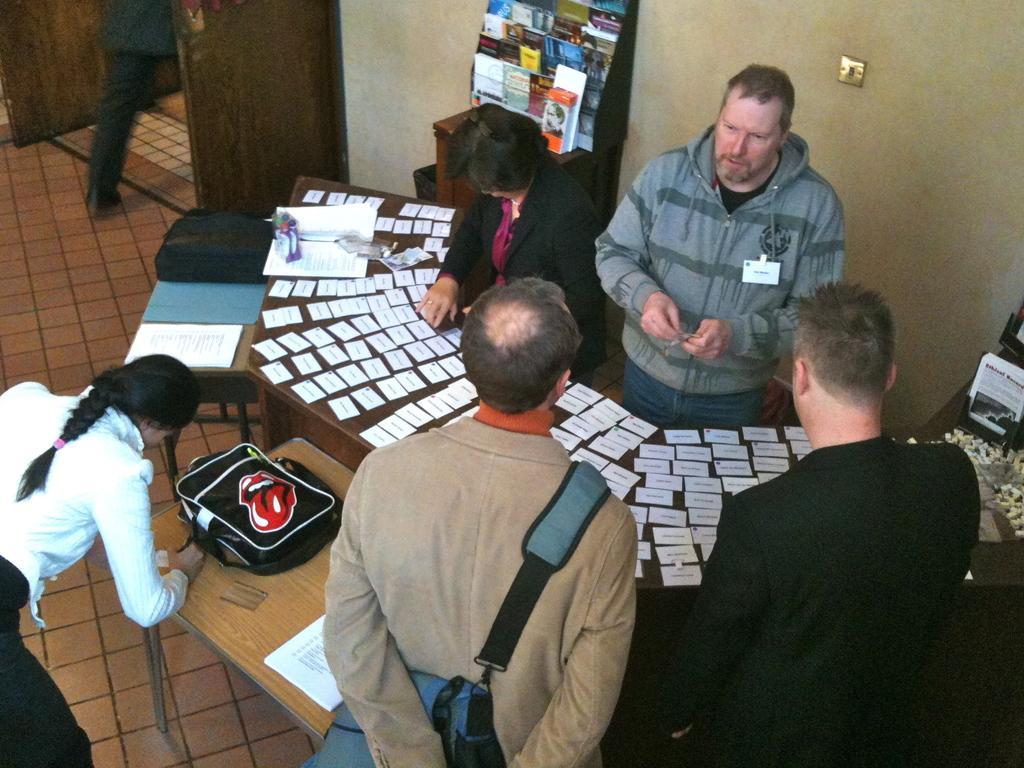Can you describe this image briefly? This picture might be taken inside the room. In this image, on the right side, we can see a man wearing a black color coat is standing in front of the table. In the middle, we can also see a man wearing a back pack is standing in front of the table. On the left corner, we can see a woman standing in front of the table, on that table, there is a book, bag, cards. In the background, we can see three people, hoardings and a wall. 